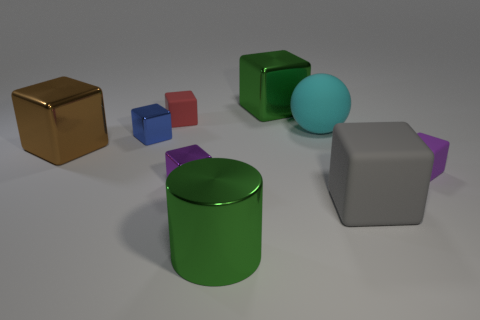There is a green object that is the same shape as the big brown object; what is its size?
Your answer should be very brief. Large. How many tiny things are either gray matte cubes or gray cylinders?
Your response must be concise. 0. What is the shape of the tiny red object?
Offer a terse response. Cube. Is there a large green thing made of the same material as the red thing?
Your response must be concise. No. Is the number of cyan rubber things greater than the number of large red cubes?
Offer a terse response. Yes. Does the big gray block have the same material as the tiny blue block?
Provide a succinct answer. No. What number of metallic objects are big green things or small purple objects?
Give a very brief answer. 3. There is another shiny block that is the same size as the blue metal cube; what color is it?
Your response must be concise. Purple. How many blue metal things are the same shape as the brown thing?
Offer a terse response. 1. How many cylinders are green matte things or green things?
Your response must be concise. 1. 